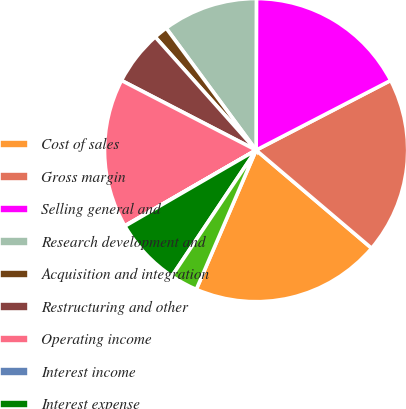Convert chart. <chart><loc_0><loc_0><loc_500><loc_500><pie_chart><fcel>Cost of sales<fcel>Gross margin<fcel>Selling general and<fcel>Research development and<fcel>Acquisition and integration<fcel>Restructuring and other<fcel>Operating income<fcel>Interest income<fcel>Interest expense<fcel>Other income net<nl><fcel>20.25%<fcel>18.81%<fcel>17.36%<fcel>10.14%<fcel>1.48%<fcel>5.81%<fcel>15.92%<fcel>0.04%<fcel>7.26%<fcel>2.92%<nl></chart> 